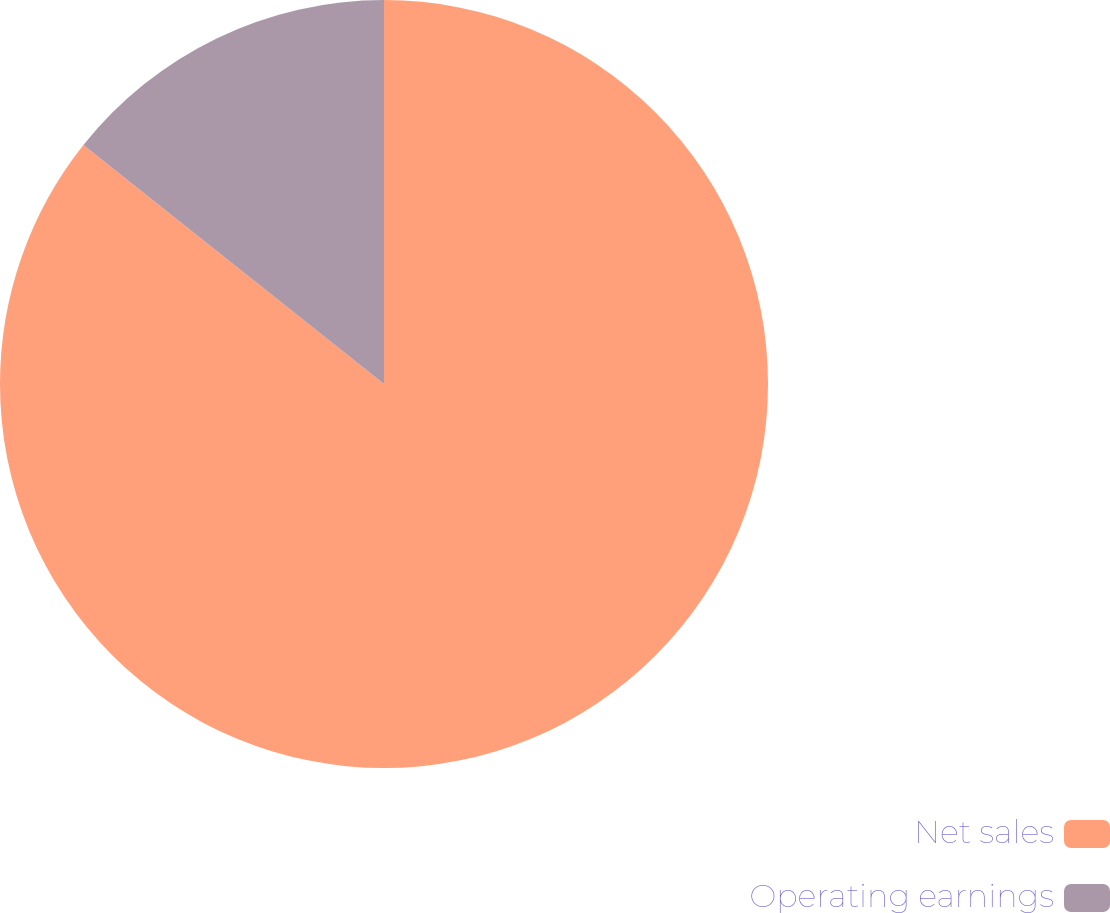Convert chart. <chart><loc_0><loc_0><loc_500><loc_500><pie_chart><fcel>Net sales<fcel>Operating earnings<nl><fcel>85.69%<fcel>14.31%<nl></chart> 